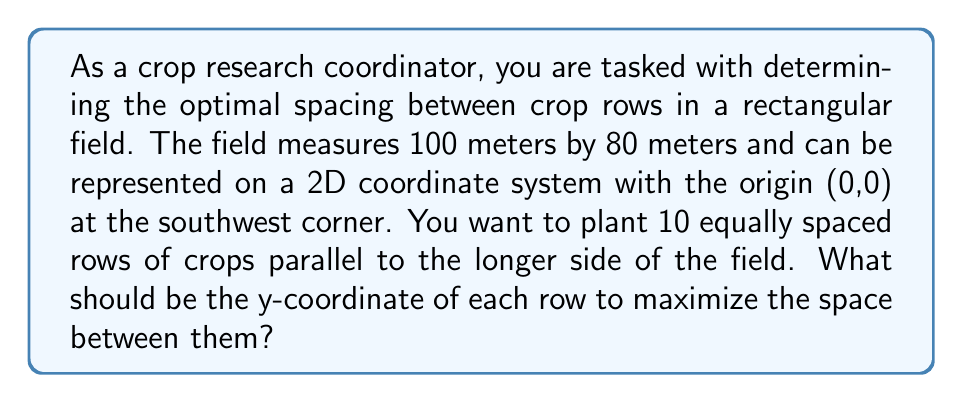What is the answer to this math problem? To solve this problem, we need to follow these steps:

1. Visualize the field on a 2D coordinate system:
   - The field is 100m x 80m
   - The origin (0,0) is at the southwest corner
   - The rows will be parallel to the x-axis (longer side)

2. Calculate the spacing between rows:
   - We need 10 equally spaced rows
   - The field is 80 meters wide (along the y-axis)
   - We need 9 spaces between the 10 rows
   - Spacing = Total width / (Number of rows + 1)
   - Spacing = 80 / (10 + 1) = 80 / 11 ≈ 7.27 meters

3. Calculate the y-coordinates of each row:
   - First row: $y_1 = 1 \times 7.27 = 7.27$
   - Second row: $y_2 = 2 \times 7.27 = 14.54$
   - Third row: $y_3 = 3 \times 7.27 = 21.81$
   - ...
   - Tenth row: $y_{10} = 10 \times 7.27 = 72.7$

We can express this as a general formula:

$$y_n = n \times \frac{80}{11}$$

Where $n$ is the row number (1 to 10) and $y_n$ is the y-coordinate of the nth row.

This spacing maximizes the distance between rows while ensuring equal distribution across the field.
Answer: The y-coordinates of the 10 rows should be approximately:
7.27m, 14.54m, 21.81m, 29.08m, 36.35m, 43.62m, 50.89m, 58.16m, 65.43m, and 72.7m.

These can be calculated using the formula: $y_n = n \times \frac{80}{11}$, where $n$ is the row number (1 to 10). 